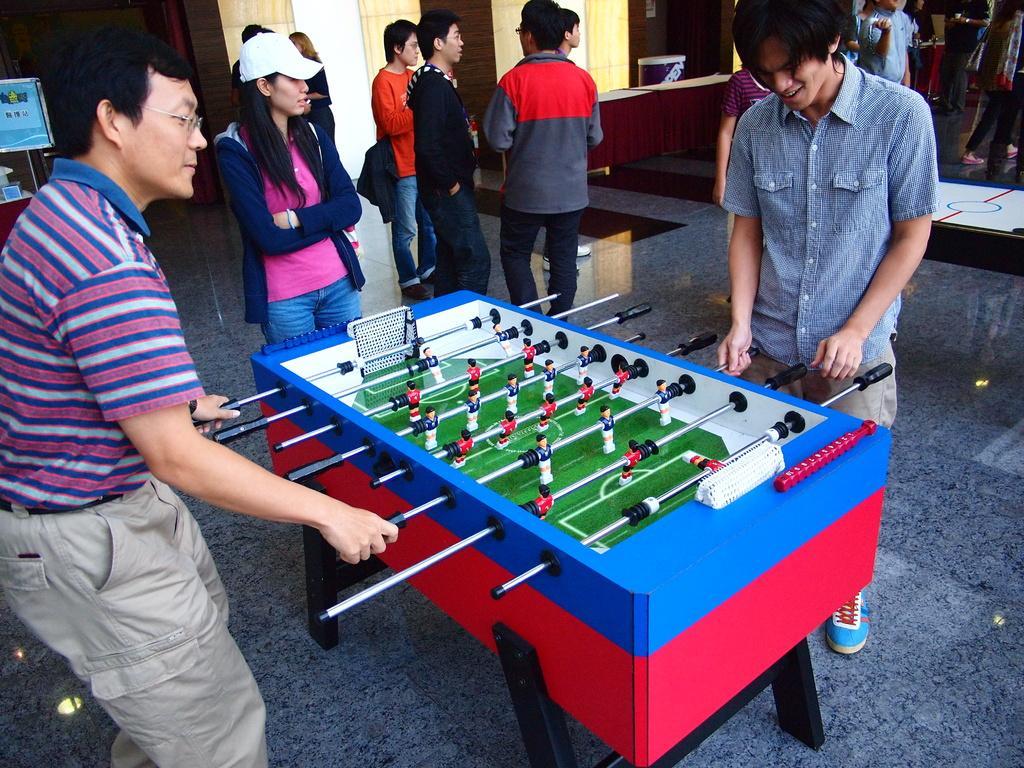In one or two sentences, can you explain what this image depicts? In this image there are two persons standing and playing Foosball, and in the background there are group of people standing, table, a board on the stand. 